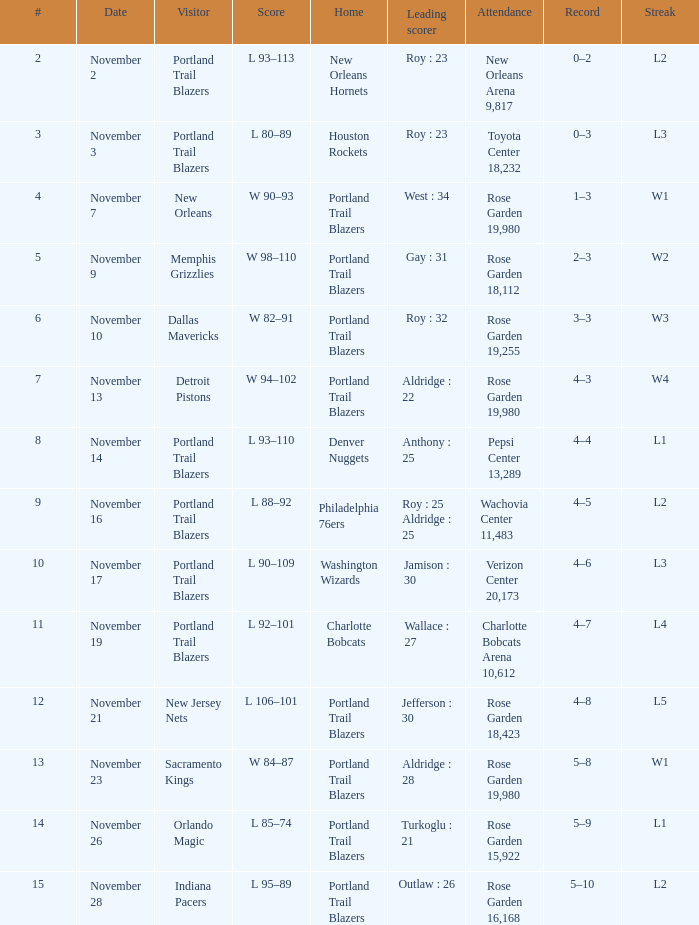What's the number of attendees when scores are from 92 to 101? Charlotte Bobcats Arena 10,612. 